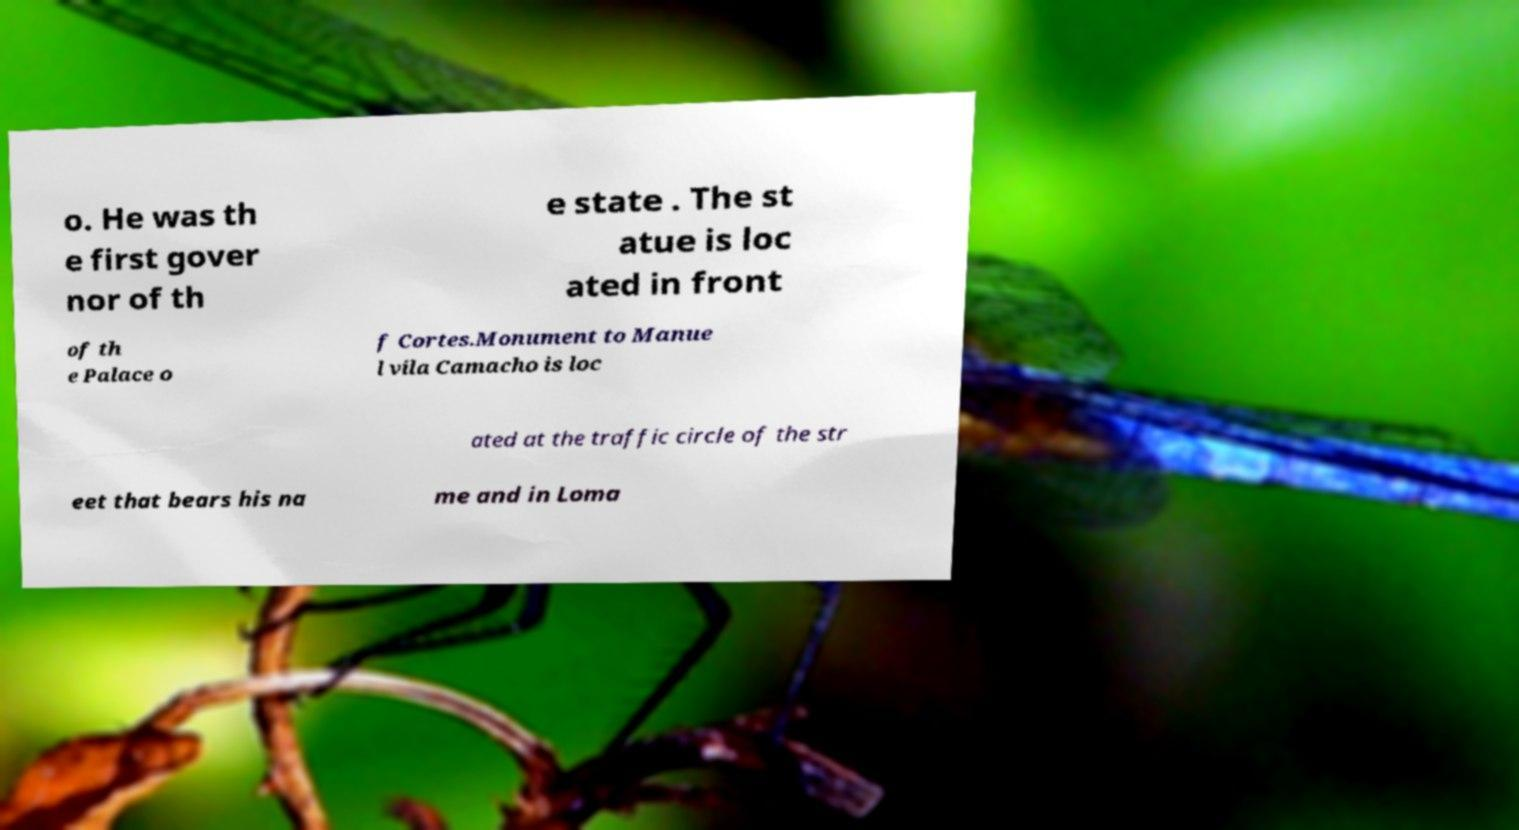Can you accurately transcribe the text from the provided image for me? o. He was th e first gover nor of th e state . The st atue is loc ated in front of th e Palace o f Cortes.Monument to Manue l vila Camacho is loc ated at the traffic circle of the str eet that bears his na me and in Loma 